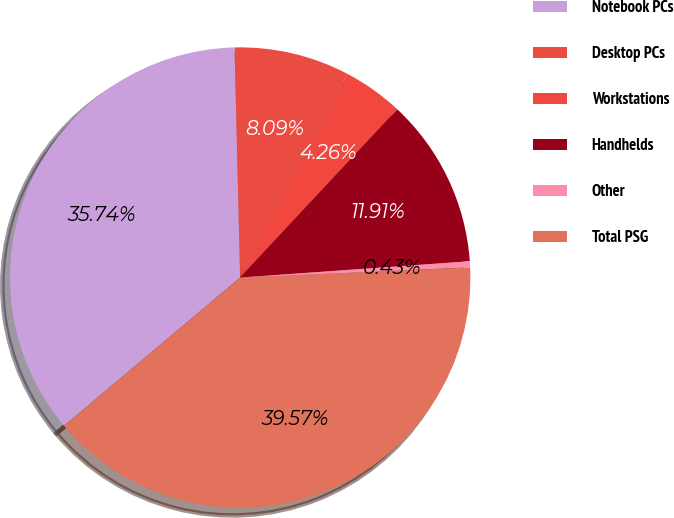Convert chart to OTSL. <chart><loc_0><loc_0><loc_500><loc_500><pie_chart><fcel>Notebook PCs<fcel>Desktop PCs<fcel>Workstations<fcel>Handhelds<fcel>Other<fcel>Total PSG<nl><fcel>35.74%<fcel>8.09%<fcel>4.26%<fcel>11.91%<fcel>0.43%<fcel>39.57%<nl></chart> 